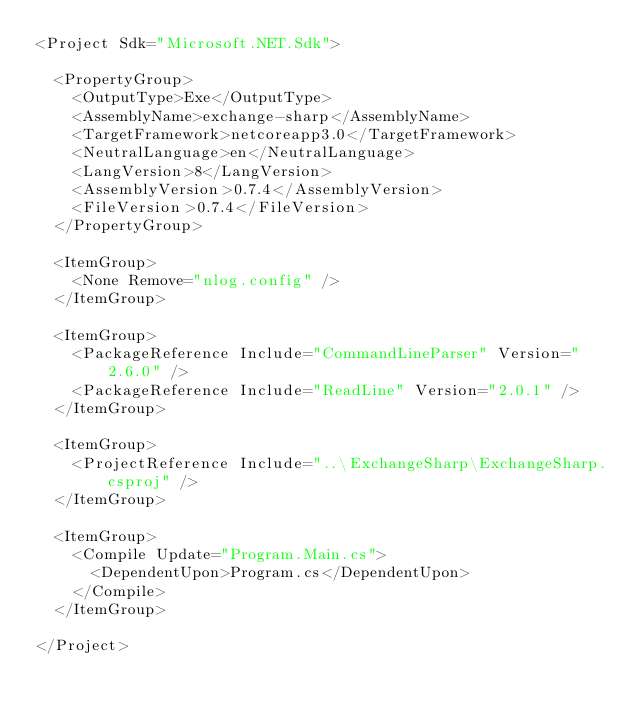Convert code to text. <code><loc_0><loc_0><loc_500><loc_500><_XML_><Project Sdk="Microsoft.NET.Sdk">

  <PropertyGroup>
    <OutputType>Exe</OutputType>
    <AssemblyName>exchange-sharp</AssemblyName>
    <TargetFramework>netcoreapp3.0</TargetFramework>
    <NeutralLanguage>en</NeutralLanguage>
    <LangVersion>8</LangVersion>
    <AssemblyVersion>0.7.4</AssemblyVersion>
    <FileVersion>0.7.4</FileVersion>
  </PropertyGroup>

  <ItemGroup>
    <None Remove="nlog.config" />
  </ItemGroup>

  <ItemGroup>
    <PackageReference Include="CommandLineParser" Version="2.6.0" />
    <PackageReference Include="ReadLine" Version="2.0.1" />
  </ItemGroup>

  <ItemGroup>
    <ProjectReference Include="..\ExchangeSharp\ExchangeSharp.csproj" />
  </ItemGroup>

  <ItemGroup>
    <Compile Update="Program.Main.cs">
      <DependentUpon>Program.cs</DependentUpon>
    </Compile>
  </ItemGroup>

</Project>
</code> 